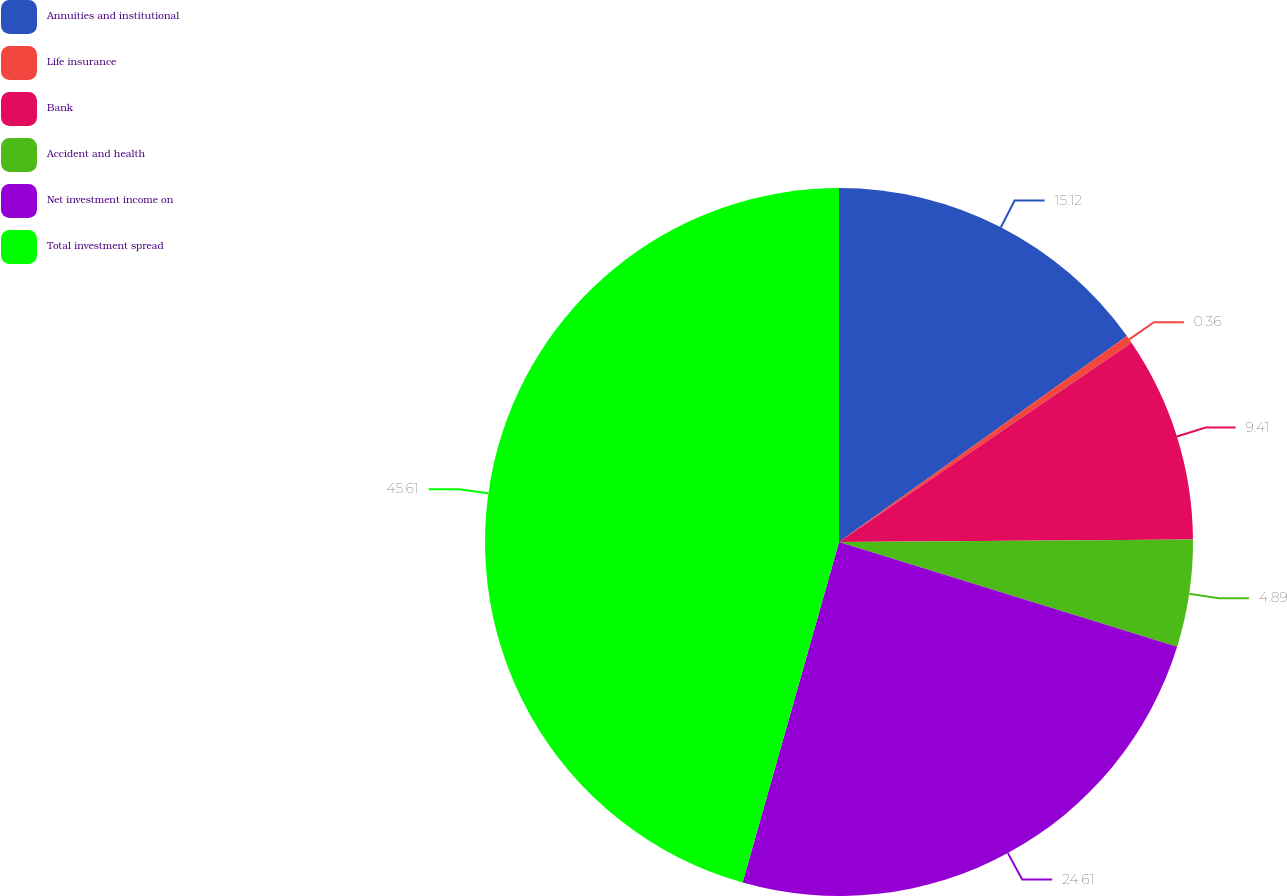Convert chart to OTSL. <chart><loc_0><loc_0><loc_500><loc_500><pie_chart><fcel>Annuities and institutional<fcel>Life insurance<fcel>Bank<fcel>Accident and health<fcel>Net investment income on<fcel>Total investment spread<nl><fcel>15.12%<fcel>0.36%<fcel>9.41%<fcel>4.89%<fcel>24.61%<fcel>45.61%<nl></chart> 